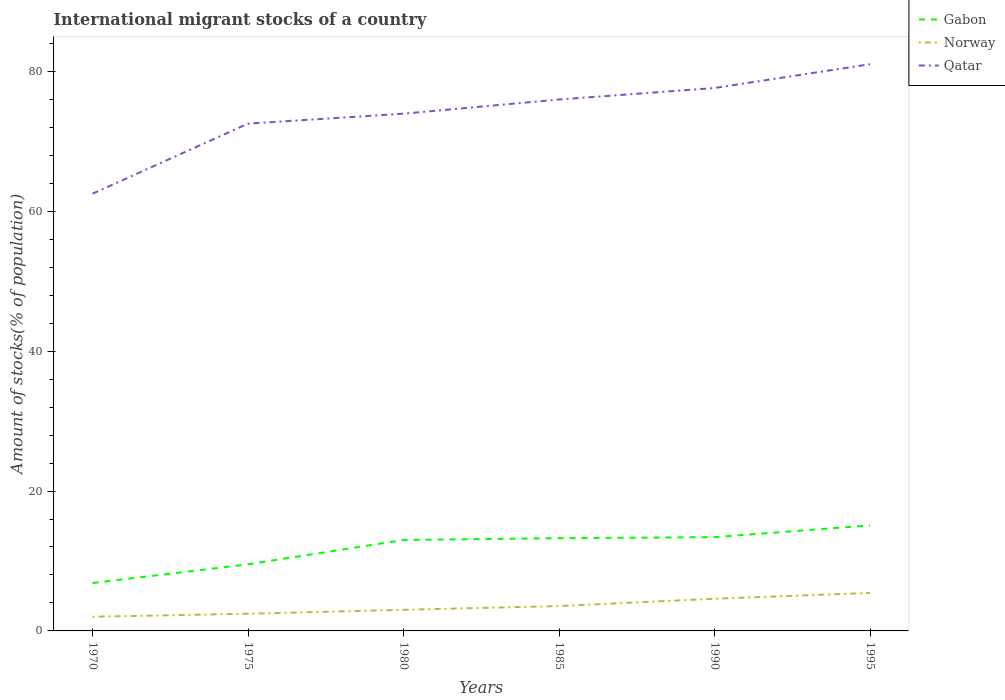Is the number of lines equal to the number of legend labels?
Keep it short and to the point. Yes. Across all years, what is the maximum amount of stocks in in Qatar?
Your answer should be very brief. 62.51. In which year was the amount of stocks in in Qatar maximum?
Make the answer very short. 1970. What is the total amount of stocks in in Qatar in the graph?
Keep it short and to the point. -18.51. What is the difference between the highest and the second highest amount of stocks in in Qatar?
Your answer should be very brief. 18.51. What is the difference between the highest and the lowest amount of stocks in in Norway?
Make the answer very short. 3. Is the amount of stocks in in Qatar strictly greater than the amount of stocks in in Gabon over the years?
Your answer should be compact. No. How many years are there in the graph?
Keep it short and to the point. 6. Does the graph contain any zero values?
Offer a terse response. No. Where does the legend appear in the graph?
Offer a very short reply. Top right. How many legend labels are there?
Give a very brief answer. 3. How are the legend labels stacked?
Your answer should be compact. Vertical. What is the title of the graph?
Your answer should be very brief. International migrant stocks of a country. Does "Senegal" appear as one of the legend labels in the graph?
Your answer should be compact. No. What is the label or title of the X-axis?
Ensure brevity in your answer.  Years. What is the label or title of the Y-axis?
Keep it short and to the point. Amount of stocks(% of population). What is the Amount of stocks(% of population) of Gabon in 1970?
Offer a very short reply. 6.84. What is the Amount of stocks(% of population) in Norway in 1970?
Provide a short and direct response. 2.03. What is the Amount of stocks(% of population) of Qatar in 1970?
Your response must be concise. 62.51. What is the Amount of stocks(% of population) in Gabon in 1975?
Your response must be concise. 9.53. What is the Amount of stocks(% of population) in Norway in 1975?
Your response must be concise. 2.46. What is the Amount of stocks(% of population) of Qatar in 1975?
Provide a short and direct response. 72.52. What is the Amount of stocks(% of population) of Gabon in 1980?
Your answer should be compact. 13. What is the Amount of stocks(% of population) in Norway in 1980?
Your response must be concise. 3.02. What is the Amount of stocks(% of population) in Qatar in 1980?
Keep it short and to the point. 73.94. What is the Amount of stocks(% of population) in Gabon in 1985?
Your answer should be compact. 13.25. What is the Amount of stocks(% of population) in Norway in 1985?
Provide a succinct answer. 3.56. What is the Amount of stocks(% of population) in Qatar in 1985?
Ensure brevity in your answer.  75.97. What is the Amount of stocks(% of population) in Gabon in 1990?
Your answer should be compact. 13.41. What is the Amount of stocks(% of population) of Norway in 1990?
Your answer should be very brief. 4.6. What is the Amount of stocks(% of population) of Qatar in 1990?
Offer a very short reply. 77.61. What is the Amount of stocks(% of population) of Gabon in 1995?
Make the answer very short. 15.09. What is the Amount of stocks(% of population) of Norway in 1995?
Make the answer very short. 5.43. What is the Amount of stocks(% of population) in Qatar in 1995?
Make the answer very short. 81.02. Across all years, what is the maximum Amount of stocks(% of population) of Gabon?
Ensure brevity in your answer.  15.09. Across all years, what is the maximum Amount of stocks(% of population) in Norway?
Your answer should be compact. 5.43. Across all years, what is the maximum Amount of stocks(% of population) of Qatar?
Ensure brevity in your answer.  81.02. Across all years, what is the minimum Amount of stocks(% of population) of Gabon?
Your answer should be compact. 6.84. Across all years, what is the minimum Amount of stocks(% of population) in Norway?
Provide a succinct answer. 2.03. Across all years, what is the minimum Amount of stocks(% of population) in Qatar?
Make the answer very short. 62.51. What is the total Amount of stocks(% of population) of Gabon in the graph?
Your response must be concise. 71.12. What is the total Amount of stocks(% of population) in Norway in the graph?
Your answer should be compact. 21.09. What is the total Amount of stocks(% of population) of Qatar in the graph?
Give a very brief answer. 443.58. What is the difference between the Amount of stocks(% of population) of Gabon in 1970 and that in 1975?
Your answer should be compact. -2.68. What is the difference between the Amount of stocks(% of population) of Norway in 1970 and that in 1975?
Provide a succinct answer. -0.43. What is the difference between the Amount of stocks(% of population) in Qatar in 1970 and that in 1975?
Your response must be concise. -10.02. What is the difference between the Amount of stocks(% of population) of Gabon in 1970 and that in 1980?
Your answer should be compact. -6.16. What is the difference between the Amount of stocks(% of population) in Norway in 1970 and that in 1980?
Your answer should be compact. -0.99. What is the difference between the Amount of stocks(% of population) in Qatar in 1970 and that in 1980?
Keep it short and to the point. -11.44. What is the difference between the Amount of stocks(% of population) of Gabon in 1970 and that in 1985?
Your answer should be compact. -6.41. What is the difference between the Amount of stocks(% of population) in Norway in 1970 and that in 1985?
Provide a succinct answer. -1.53. What is the difference between the Amount of stocks(% of population) in Qatar in 1970 and that in 1985?
Your answer should be very brief. -13.46. What is the difference between the Amount of stocks(% of population) of Gabon in 1970 and that in 1990?
Keep it short and to the point. -6.56. What is the difference between the Amount of stocks(% of population) in Norway in 1970 and that in 1990?
Provide a succinct answer. -2.58. What is the difference between the Amount of stocks(% of population) of Qatar in 1970 and that in 1990?
Provide a short and direct response. -15.11. What is the difference between the Amount of stocks(% of population) in Gabon in 1970 and that in 1995?
Make the answer very short. -8.24. What is the difference between the Amount of stocks(% of population) of Norway in 1970 and that in 1995?
Provide a short and direct response. -3.41. What is the difference between the Amount of stocks(% of population) in Qatar in 1970 and that in 1995?
Your response must be concise. -18.51. What is the difference between the Amount of stocks(% of population) of Gabon in 1975 and that in 1980?
Your response must be concise. -3.48. What is the difference between the Amount of stocks(% of population) in Norway in 1975 and that in 1980?
Provide a succinct answer. -0.56. What is the difference between the Amount of stocks(% of population) of Qatar in 1975 and that in 1980?
Offer a terse response. -1.42. What is the difference between the Amount of stocks(% of population) in Gabon in 1975 and that in 1985?
Ensure brevity in your answer.  -3.73. What is the difference between the Amount of stocks(% of population) in Norway in 1975 and that in 1985?
Make the answer very short. -1.1. What is the difference between the Amount of stocks(% of population) in Qatar in 1975 and that in 1985?
Ensure brevity in your answer.  -3.45. What is the difference between the Amount of stocks(% of population) of Gabon in 1975 and that in 1990?
Ensure brevity in your answer.  -3.88. What is the difference between the Amount of stocks(% of population) in Norway in 1975 and that in 1990?
Your answer should be compact. -2.14. What is the difference between the Amount of stocks(% of population) in Qatar in 1975 and that in 1990?
Your answer should be very brief. -5.09. What is the difference between the Amount of stocks(% of population) in Gabon in 1975 and that in 1995?
Keep it short and to the point. -5.56. What is the difference between the Amount of stocks(% of population) of Norway in 1975 and that in 1995?
Keep it short and to the point. -2.97. What is the difference between the Amount of stocks(% of population) in Qatar in 1975 and that in 1995?
Offer a terse response. -8.49. What is the difference between the Amount of stocks(% of population) in Gabon in 1980 and that in 1985?
Ensure brevity in your answer.  -0.25. What is the difference between the Amount of stocks(% of population) in Norway in 1980 and that in 1985?
Give a very brief answer. -0.54. What is the difference between the Amount of stocks(% of population) in Qatar in 1980 and that in 1985?
Keep it short and to the point. -2.03. What is the difference between the Amount of stocks(% of population) in Gabon in 1980 and that in 1990?
Ensure brevity in your answer.  -0.4. What is the difference between the Amount of stocks(% of population) in Norway in 1980 and that in 1990?
Ensure brevity in your answer.  -1.59. What is the difference between the Amount of stocks(% of population) in Qatar in 1980 and that in 1990?
Provide a short and direct response. -3.67. What is the difference between the Amount of stocks(% of population) of Gabon in 1980 and that in 1995?
Your answer should be very brief. -2.08. What is the difference between the Amount of stocks(% of population) of Norway in 1980 and that in 1995?
Provide a succinct answer. -2.41. What is the difference between the Amount of stocks(% of population) in Qatar in 1980 and that in 1995?
Your response must be concise. -7.07. What is the difference between the Amount of stocks(% of population) of Gabon in 1985 and that in 1990?
Offer a very short reply. -0.15. What is the difference between the Amount of stocks(% of population) of Norway in 1985 and that in 1990?
Offer a terse response. -1.05. What is the difference between the Amount of stocks(% of population) of Qatar in 1985 and that in 1990?
Keep it short and to the point. -1.64. What is the difference between the Amount of stocks(% of population) of Gabon in 1985 and that in 1995?
Your answer should be compact. -1.83. What is the difference between the Amount of stocks(% of population) of Norway in 1985 and that in 1995?
Your answer should be compact. -1.88. What is the difference between the Amount of stocks(% of population) in Qatar in 1985 and that in 1995?
Provide a short and direct response. -5.05. What is the difference between the Amount of stocks(% of population) in Gabon in 1990 and that in 1995?
Ensure brevity in your answer.  -1.68. What is the difference between the Amount of stocks(% of population) in Norway in 1990 and that in 1995?
Provide a succinct answer. -0.83. What is the difference between the Amount of stocks(% of population) in Qatar in 1990 and that in 1995?
Provide a short and direct response. -3.4. What is the difference between the Amount of stocks(% of population) of Gabon in 1970 and the Amount of stocks(% of population) of Norway in 1975?
Ensure brevity in your answer.  4.38. What is the difference between the Amount of stocks(% of population) in Gabon in 1970 and the Amount of stocks(% of population) in Qatar in 1975?
Provide a succinct answer. -65.68. What is the difference between the Amount of stocks(% of population) of Norway in 1970 and the Amount of stocks(% of population) of Qatar in 1975?
Your response must be concise. -70.5. What is the difference between the Amount of stocks(% of population) in Gabon in 1970 and the Amount of stocks(% of population) in Norway in 1980?
Make the answer very short. 3.83. What is the difference between the Amount of stocks(% of population) of Gabon in 1970 and the Amount of stocks(% of population) of Qatar in 1980?
Give a very brief answer. -67.1. What is the difference between the Amount of stocks(% of population) of Norway in 1970 and the Amount of stocks(% of population) of Qatar in 1980?
Offer a terse response. -71.92. What is the difference between the Amount of stocks(% of population) in Gabon in 1970 and the Amount of stocks(% of population) in Norway in 1985?
Give a very brief answer. 3.29. What is the difference between the Amount of stocks(% of population) in Gabon in 1970 and the Amount of stocks(% of population) in Qatar in 1985?
Your answer should be very brief. -69.13. What is the difference between the Amount of stocks(% of population) of Norway in 1970 and the Amount of stocks(% of population) of Qatar in 1985?
Keep it short and to the point. -73.95. What is the difference between the Amount of stocks(% of population) in Gabon in 1970 and the Amount of stocks(% of population) in Norway in 1990?
Your answer should be compact. 2.24. What is the difference between the Amount of stocks(% of population) in Gabon in 1970 and the Amount of stocks(% of population) in Qatar in 1990?
Provide a short and direct response. -70.77. What is the difference between the Amount of stocks(% of population) of Norway in 1970 and the Amount of stocks(% of population) of Qatar in 1990?
Provide a succinct answer. -75.59. What is the difference between the Amount of stocks(% of population) in Gabon in 1970 and the Amount of stocks(% of population) in Norway in 1995?
Make the answer very short. 1.41. What is the difference between the Amount of stocks(% of population) of Gabon in 1970 and the Amount of stocks(% of population) of Qatar in 1995?
Provide a succinct answer. -74.17. What is the difference between the Amount of stocks(% of population) of Norway in 1970 and the Amount of stocks(% of population) of Qatar in 1995?
Give a very brief answer. -78.99. What is the difference between the Amount of stocks(% of population) of Gabon in 1975 and the Amount of stocks(% of population) of Norway in 1980?
Your answer should be very brief. 6.51. What is the difference between the Amount of stocks(% of population) in Gabon in 1975 and the Amount of stocks(% of population) in Qatar in 1980?
Your response must be concise. -64.42. What is the difference between the Amount of stocks(% of population) of Norway in 1975 and the Amount of stocks(% of population) of Qatar in 1980?
Ensure brevity in your answer.  -71.48. What is the difference between the Amount of stocks(% of population) of Gabon in 1975 and the Amount of stocks(% of population) of Norway in 1985?
Your answer should be compact. 5.97. What is the difference between the Amount of stocks(% of population) of Gabon in 1975 and the Amount of stocks(% of population) of Qatar in 1985?
Offer a terse response. -66.45. What is the difference between the Amount of stocks(% of population) of Norway in 1975 and the Amount of stocks(% of population) of Qatar in 1985?
Ensure brevity in your answer.  -73.51. What is the difference between the Amount of stocks(% of population) in Gabon in 1975 and the Amount of stocks(% of population) in Norway in 1990?
Offer a very short reply. 4.92. What is the difference between the Amount of stocks(% of population) of Gabon in 1975 and the Amount of stocks(% of population) of Qatar in 1990?
Your response must be concise. -68.09. What is the difference between the Amount of stocks(% of population) in Norway in 1975 and the Amount of stocks(% of population) in Qatar in 1990?
Offer a very short reply. -75.15. What is the difference between the Amount of stocks(% of population) in Gabon in 1975 and the Amount of stocks(% of population) in Norway in 1995?
Give a very brief answer. 4.09. What is the difference between the Amount of stocks(% of population) of Gabon in 1975 and the Amount of stocks(% of population) of Qatar in 1995?
Provide a short and direct response. -71.49. What is the difference between the Amount of stocks(% of population) in Norway in 1975 and the Amount of stocks(% of population) in Qatar in 1995?
Offer a terse response. -78.56. What is the difference between the Amount of stocks(% of population) in Gabon in 1980 and the Amount of stocks(% of population) in Norway in 1985?
Provide a short and direct response. 9.45. What is the difference between the Amount of stocks(% of population) of Gabon in 1980 and the Amount of stocks(% of population) of Qatar in 1985?
Keep it short and to the point. -62.97. What is the difference between the Amount of stocks(% of population) of Norway in 1980 and the Amount of stocks(% of population) of Qatar in 1985?
Offer a very short reply. -72.95. What is the difference between the Amount of stocks(% of population) in Gabon in 1980 and the Amount of stocks(% of population) in Norway in 1990?
Your answer should be compact. 8.4. What is the difference between the Amount of stocks(% of population) of Gabon in 1980 and the Amount of stocks(% of population) of Qatar in 1990?
Ensure brevity in your answer.  -64.61. What is the difference between the Amount of stocks(% of population) of Norway in 1980 and the Amount of stocks(% of population) of Qatar in 1990?
Provide a succinct answer. -74.6. What is the difference between the Amount of stocks(% of population) in Gabon in 1980 and the Amount of stocks(% of population) in Norway in 1995?
Give a very brief answer. 7.57. What is the difference between the Amount of stocks(% of population) of Gabon in 1980 and the Amount of stocks(% of population) of Qatar in 1995?
Make the answer very short. -68.01. What is the difference between the Amount of stocks(% of population) of Norway in 1980 and the Amount of stocks(% of population) of Qatar in 1995?
Your response must be concise. -78. What is the difference between the Amount of stocks(% of population) of Gabon in 1985 and the Amount of stocks(% of population) of Norway in 1990?
Your answer should be compact. 8.65. What is the difference between the Amount of stocks(% of population) in Gabon in 1985 and the Amount of stocks(% of population) in Qatar in 1990?
Provide a succinct answer. -64.36. What is the difference between the Amount of stocks(% of population) of Norway in 1985 and the Amount of stocks(% of population) of Qatar in 1990?
Give a very brief answer. -74.06. What is the difference between the Amount of stocks(% of population) of Gabon in 1985 and the Amount of stocks(% of population) of Norway in 1995?
Provide a short and direct response. 7.82. What is the difference between the Amount of stocks(% of population) of Gabon in 1985 and the Amount of stocks(% of population) of Qatar in 1995?
Provide a succinct answer. -67.76. What is the difference between the Amount of stocks(% of population) of Norway in 1985 and the Amount of stocks(% of population) of Qatar in 1995?
Offer a very short reply. -77.46. What is the difference between the Amount of stocks(% of population) in Gabon in 1990 and the Amount of stocks(% of population) in Norway in 1995?
Keep it short and to the point. 7.98. What is the difference between the Amount of stocks(% of population) of Gabon in 1990 and the Amount of stocks(% of population) of Qatar in 1995?
Offer a very short reply. -67.61. What is the difference between the Amount of stocks(% of population) of Norway in 1990 and the Amount of stocks(% of population) of Qatar in 1995?
Ensure brevity in your answer.  -76.42. What is the average Amount of stocks(% of population) of Gabon per year?
Offer a very short reply. 11.85. What is the average Amount of stocks(% of population) of Norway per year?
Ensure brevity in your answer.  3.52. What is the average Amount of stocks(% of population) in Qatar per year?
Provide a short and direct response. 73.93. In the year 1970, what is the difference between the Amount of stocks(% of population) of Gabon and Amount of stocks(% of population) of Norway?
Offer a very short reply. 4.82. In the year 1970, what is the difference between the Amount of stocks(% of population) in Gabon and Amount of stocks(% of population) in Qatar?
Keep it short and to the point. -55.66. In the year 1970, what is the difference between the Amount of stocks(% of population) of Norway and Amount of stocks(% of population) of Qatar?
Offer a terse response. -60.48. In the year 1975, what is the difference between the Amount of stocks(% of population) of Gabon and Amount of stocks(% of population) of Norway?
Offer a terse response. 7.06. In the year 1975, what is the difference between the Amount of stocks(% of population) of Gabon and Amount of stocks(% of population) of Qatar?
Provide a short and direct response. -63. In the year 1975, what is the difference between the Amount of stocks(% of population) of Norway and Amount of stocks(% of population) of Qatar?
Your answer should be compact. -70.06. In the year 1980, what is the difference between the Amount of stocks(% of population) of Gabon and Amount of stocks(% of population) of Norway?
Your answer should be very brief. 9.99. In the year 1980, what is the difference between the Amount of stocks(% of population) of Gabon and Amount of stocks(% of population) of Qatar?
Your answer should be very brief. -60.94. In the year 1980, what is the difference between the Amount of stocks(% of population) of Norway and Amount of stocks(% of population) of Qatar?
Provide a short and direct response. -70.93. In the year 1985, what is the difference between the Amount of stocks(% of population) in Gabon and Amount of stocks(% of population) in Norway?
Keep it short and to the point. 9.7. In the year 1985, what is the difference between the Amount of stocks(% of population) of Gabon and Amount of stocks(% of population) of Qatar?
Your response must be concise. -62.72. In the year 1985, what is the difference between the Amount of stocks(% of population) of Norway and Amount of stocks(% of population) of Qatar?
Provide a short and direct response. -72.42. In the year 1990, what is the difference between the Amount of stocks(% of population) of Gabon and Amount of stocks(% of population) of Norway?
Offer a very short reply. 8.8. In the year 1990, what is the difference between the Amount of stocks(% of population) of Gabon and Amount of stocks(% of population) of Qatar?
Provide a short and direct response. -64.21. In the year 1990, what is the difference between the Amount of stocks(% of population) in Norway and Amount of stocks(% of population) in Qatar?
Ensure brevity in your answer.  -73.01. In the year 1995, what is the difference between the Amount of stocks(% of population) of Gabon and Amount of stocks(% of population) of Norway?
Ensure brevity in your answer.  9.66. In the year 1995, what is the difference between the Amount of stocks(% of population) of Gabon and Amount of stocks(% of population) of Qatar?
Your response must be concise. -65.93. In the year 1995, what is the difference between the Amount of stocks(% of population) in Norway and Amount of stocks(% of population) in Qatar?
Your response must be concise. -75.59. What is the ratio of the Amount of stocks(% of population) of Gabon in 1970 to that in 1975?
Keep it short and to the point. 0.72. What is the ratio of the Amount of stocks(% of population) in Norway in 1970 to that in 1975?
Ensure brevity in your answer.  0.82. What is the ratio of the Amount of stocks(% of population) in Qatar in 1970 to that in 1975?
Your response must be concise. 0.86. What is the ratio of the Amount of stocks(% of population) in Gabon in 1970 to that in 1980?
Provide a short and direct response. 0.53. What is the ratio of the Amount of stocks(% of population) in Norway in 1970 to that in 1980?
Offer a terse response. 0.67. What is the ratio of the Amount of stocks(% of population) of Qatar in 1970 to that in 1980?
Provide a short and direct response. 0.85. What is the ratio of the Amount of stocks(% of population) of Gabon in 1970 to that in 1985?
Offer a very short reply. 0.52. What is the ratio of the Amount of stocks(% of population) of Norway in 1970 to that in 1985?
Your answer should be compact. 0.57. What is the ratio of the Amount of stocks(% of population) of Qatar in 1970 to that in 1985?
Offer a very short reply. 0.82. What is the ratio of the Amount of stocks(% of population) of Gabon in 1970 to that in 1990?
Offer a terse response. 0.51. What is the ratio of the Amount of stocks(% of population) in Norway in 1970 to that in 1990?
Provide a short and direct response. 0.44. What is the ratio of the Amount of stocks(% of population) in Qatar in 1970 to that in 1990?
Your response must be concise. 0.81. What is the ratio of the Amount of stocks(% of population) of Gabon in 1970 to that in 1995?
Your answer should be very brief. 0.45. What is the ratio of the Amount of stocks(% of population) in Norway in 1970 to that in 1995?
Provide a succinct answer. 0.37. What is the ratio of the Amount of stocks(% of population) in Qatar in 1970 to that in 1995?
Keep it short and to the point. 0.77. What is the ratio of the Amount of stocks(% of population) in Gabon in 1975 to that in 1980?
Offer a terse response. 0.73. What is the ratio of the Amount of stocks(% of population) of Norway in 1975 to that in 1980?
Your answer should be compact. 0.82. What is the ratio of the Amount of stocks(% of population) of Qatar in 1975 to that in 1980?
Give a very brief answer. 0.98. What is the ratio of the Amount of stocks(% of population) in Gabon in 1975 to that in 1985?
Your answer should be compact. 0.72. What is the ratio of the Amount of stocks(% of population) of Norway in 1975 to that in 1985?
Offer a terse response. 0.69. What is the ratio of the Amount of stocks(% of population) of Qatar in 1975 to that in 1985?
Offer a very short reply. 0.95. What is the ratio of the Amount of stocks(% of population) in Gabon in 1975 to that in 1990?
Your response must be concise. 0.71. What is the ratio of the Amount of stocks(% of population) in Norway in 1975 to that in 1990?
Your response must be concise. 0.53. What is the ratio of the Amount of stocks(% of population) of Qatar in 1975 to that in 1990?
Give a very brief answer. 0.93. What is the ratio of the Amount of stocks(% of population) in Gabon in 1975 to that in 1995?
Make the answer very short. 0.63. What is the ratio of the Amount of stocks(% of population) in Norway in 1975 to that in 1995?
Offer a terse response. 0.45. What is the ratio of the Amount of stocks(% of population) in Qatar in 1975 to that in 1995?
Offer a very short reply. 0.9. What is the ratio of the Amount of stocks(% of population) in Gabon in 1980 to that in 1985?
Your answer should be very brief. 0.98. What is the ratio of the Amount of stocks(% of population) in Norway in 1980 to that in 1985?
Provide a short and direct response. 0.85. What is the ratio of the Amount of stocks(% of population) of Qatar in 1980 to that in 1985?
Your answer should be very brief. 0.97. What is the ratio of the Amount of stocks(% of population) in Gabon in 1980 to that in 1990?
Provide a short and direct response. 0.97. What is the ratio of the Amount of stocks(% of population) of Norway in 1980 to that in 1990?
Keep it short and to the point. 0.66. What is the ratio of the Amount of stocks(% of population) of Qatar in 1980 to that in 1990?
Your answer should be very brief. 0.95. What is the ratio of the Amount of stocks(% of population) in Gabon in 1980 to that in 1995?
Ensure brevity in your answer.  0.86. What is the ratio of the Amount of stocks(% of population) in Norway in 1980 to that in 1995?
Provide a succinct answer. 0.56. What is the ratio of the Amount of stocks(% of population) of Qatar in 1980 to that in 1995?
Make the answer very short. 0.91. What is the ratio of the Amount of stocks(% of population) of Gabon in 1985 to that in 1990?
Your answer should be compact. 0.99. What is the ratio of the Amount of stocks(% of population) in Norway in 1985 to that in 1990?
Your answer should be compact. 0.77. What is the ratio of the Amount of stocks(% of population) of Qatar in 1985 to that in 1990?
Offer a terse response. 0.98. What is the ratio of the Amount of stocks(% of population) of Gabon in 1985 to that in 1995?
Offer a very short reply. 0.88. What is the ratio of the Amount of stocks(% of population) in Norway in 1985 to that in 1995?
Provide a succinct answer. 0.65. What is the ratio of the Amount of stocks(% of population) of Qatar in 1985 to that in 1995?
Offer a terse response. 0.94. What is the ratio of the Amount of stocks(% of population) in Gabon in 1990 to that in 1995?
Your response must be concise. 0.89. What is the ratio of the Amount of stocks(% of population) in Norway in 1990 to that in 1995?
Give a very brief answer. 0.85. What is the ratio of the Amount of stocks(% of population) of Qatar in 1990 to that in 1995?
Offer a very short reply. 0.96. What is the difference between the highest and the second highest Amount of stocks(% of population) of Gabon?
Ensure brevity in your answer.  1.68. What is the difference between the highest and the second highest Amount of stocks(% of population) in Norway?
Provide a succinct answer. 0.83. What is the difference between the highest and the second highest Amount of stocks(% of population) in Qatar?
Your response must be concise. 3.4. What is the difference between the highest and the lowest Amount of stocks(% of population) in Gabon?
Ensure brevity in your answer.  8.24. What is the difference between the highest and the lowest Amount of stocks(% of population) in Norway?
Provide a short and direct response. 3.41. What is the difference between the highest and the lowest Amount of stocks(% of population) in Qatar?
Provide a short and direct response. 18.51. 